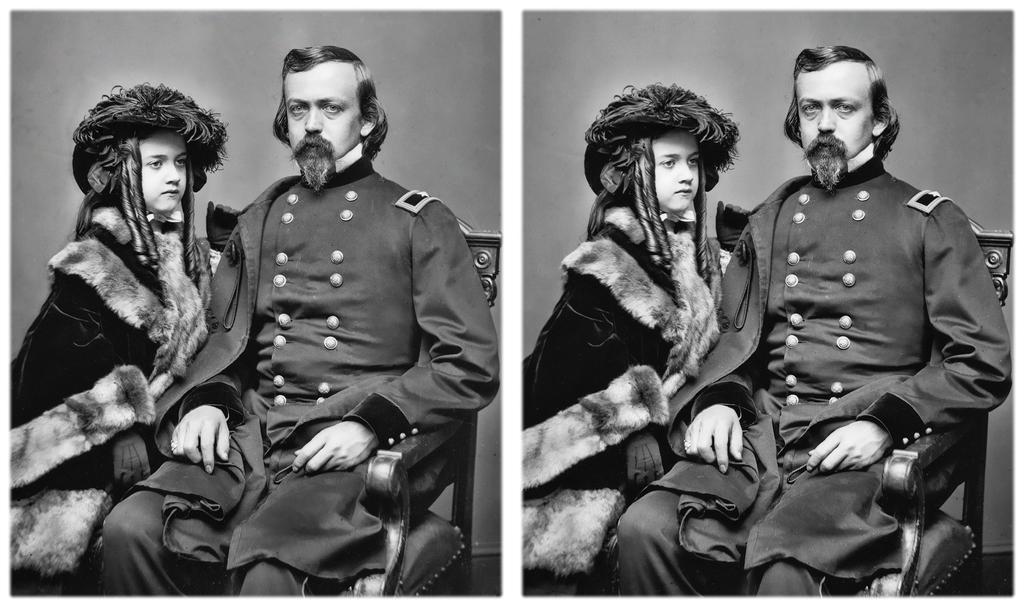In one or two sentences, can you explain what this image depicts? I see this is a collage image and I see that this is a black and white picture and I see a man who is sitting on a chair and I see a child standing near to him. 